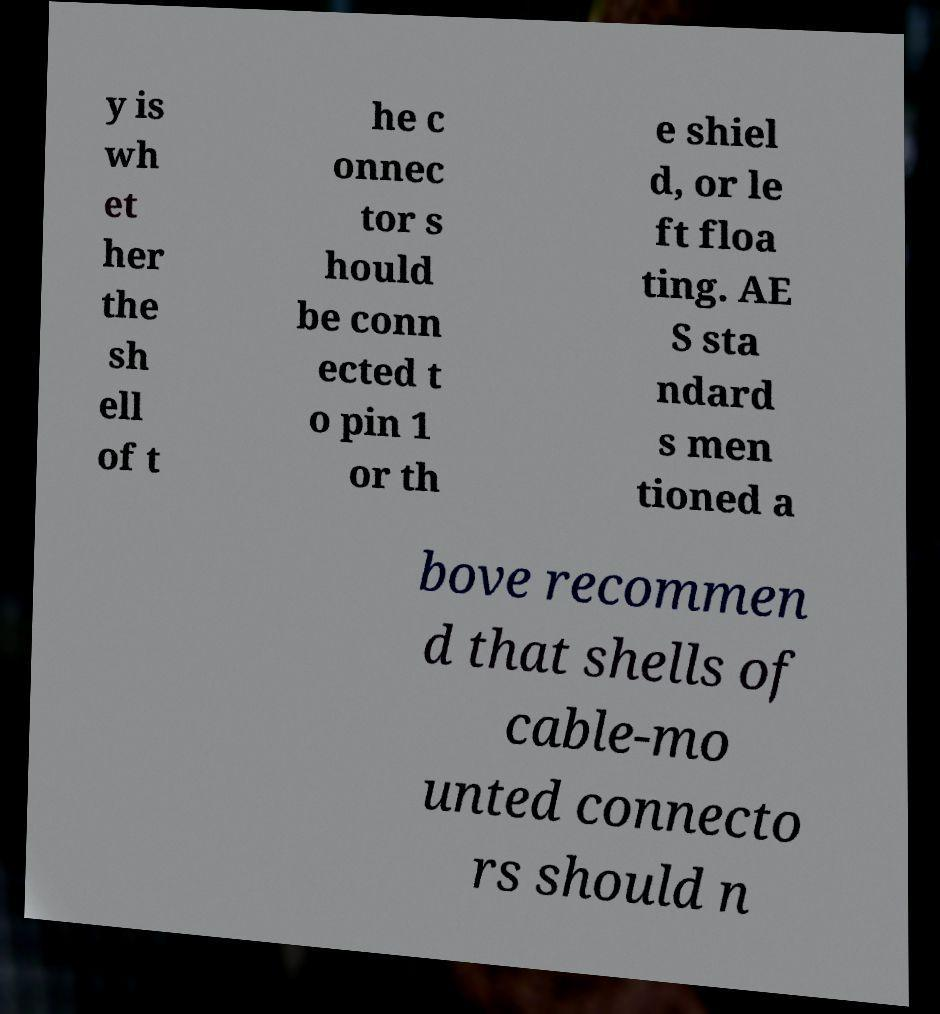I need the written content from this picture converted into text. Can you do that? y is wh et her the sh ell of t he c onnec tor s hould be conn ected t o pin 1 or th e shiel d, or le ft floa ting. AE S sta ndard s men tioned a bove recommen d that shells of cable-mo unted connecto rs should n 